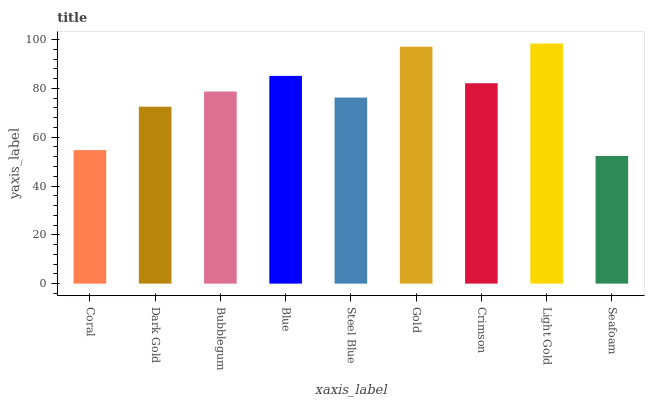Is Seafoam the minimum?
Answer yes or no. Yes. Is Light Gold the maximum?
Answer yes or no. Yes. Is Dark Gold the minimum?
Answer yes or no. No. Is Dark Gold the maximum?
Answer yes or no. No. Is Dark Gold greater than Coral?
Answer yes or no. Yes. Is Coral less than Dark Gold?
Answer yes or no. Yes. Is Coral greater than Dark Gold?
Answer yes or no. No. Is Dark Gold less than Coral?
Answer yes or no. No. Is Bubblegum the high median?
Answer yes or no. Yes. Is Bubblegum the low median?
Answer yes or no. Yes. Is Light Gold the high median?
Answer yes or no. No. Is Seafoam the low median?
Answer yes or no. No. 